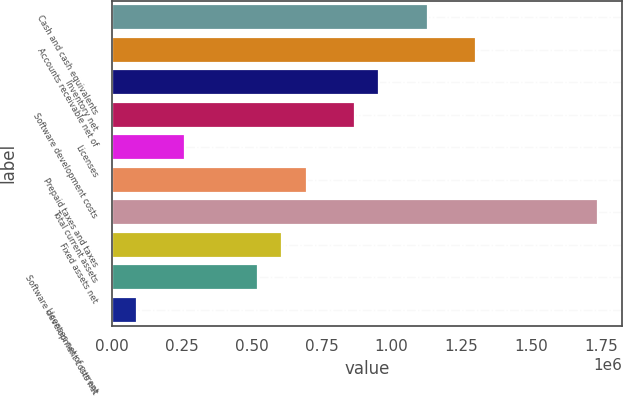Convert chart. <chart><loc_0><loc_0><loc_500><loc_500><bar_chart><fcel>Cash and cash equivalents<fcel>Accounts receivable net of<fcel>Inventory net<fcel>Software development costs<fcel>Licenses<fcel>Prepaid taxes and taxes<fcel>Total current assets<fcel>Fixed assets net<fcel>Software development costs net<fcel>Licenses net of current<nl><fcel>1.12923e+06<fcel>1.30285e+06<fcel>955614<fcel>868806<fcel>261151<fcel>695190<fcel>1.73688e+06<fcel>608382<fcel>521574<fcel>87534.9<nl></chart> 